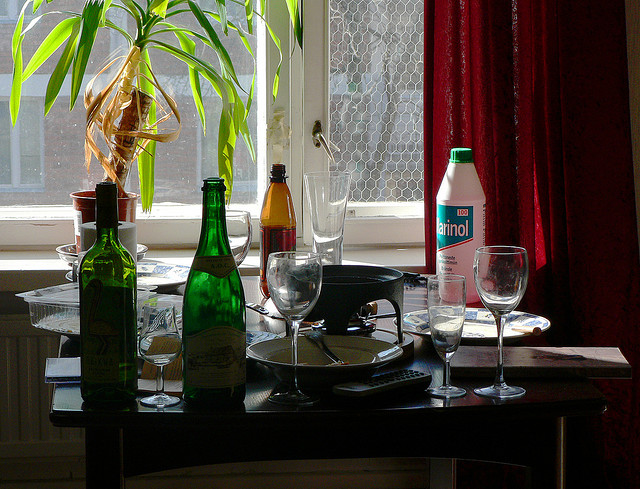<image>What is in the glass? It is unknown what is in the glass. It might be empty, or contain some liquid or wine. What is in the glass? I am not sure what is in the glass. It can be empty, contain liquid, or wine. 